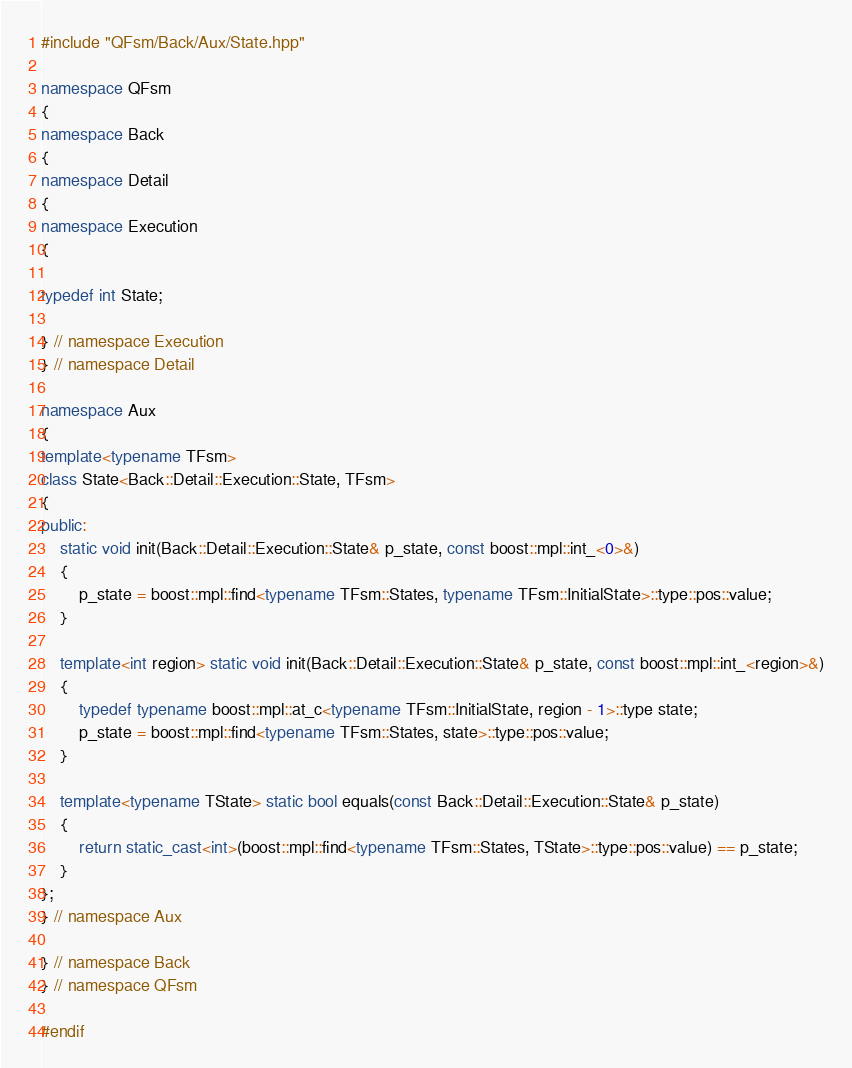Convert code to text. <code><loc_0><loc_0><loc_500><loc_500><_C++_>#include "QFsm/Back/Aux/State.hpp"

namespace QFsm
{
namespace Back
{
namespace Detail
{
namespace Execution
{

typedef int State;

} // namespace Execution
} // namespace Detail

namespace Aux
{
template<typename TFsm>
class State<Back::Detail::Execution::State, TFsm>
{
public:
    static void init(Back::Detail::Execution::State& p_state, const boost::mpl::int_<0>&)
    {
        p_state = boost::mpl::find<typename TFsm::States, typename TFsm::InitialState>::type::pos::value;
    }

    template<int region> static void init(Back::Detail::Execution::State& p_state, const boost::mpl::int_<region>&)
    {
        typedef typename boost::mpl::at_c<typename TFsm::InitialState, region - 1>::type state;
        p_state = boost::mpl::find<typename TFsm::States, state>::type::pos::value;
    }

    template<typename TState> static bool equals(const Back::Detail::Execution::State& p_state)
    {
        return static_cast<int>(boost::mpl::find<typename TFsm::States, TState>::type::pos::value) == p_state;
    }
};
} // namespace Aux

} // namespace Back
} // namespace QFsm

#endif

</code> 